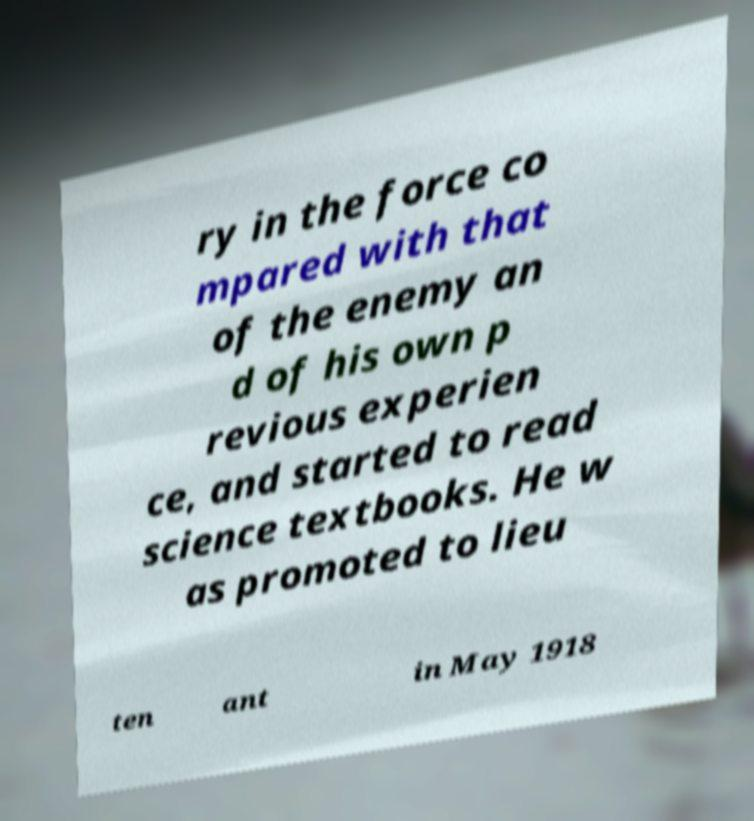Could you extract and type out the text from this image? ry in the force co mpared with that of the enemy an d of his own p revious experien ce, and started to read science textbooks. He w as promoted to lieu ten ant in May 1918 